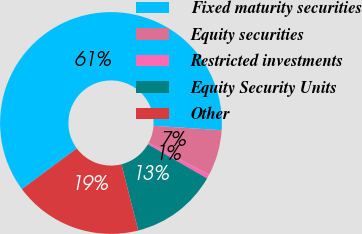Convert chart to OTSL. <chart><loc_0><loc_0><loc_500><loc_500><pie_chart><fcel>Fixed maturity securities<fcel>Equity securities<fcel>Restricted investments<fcel>Equity Security Units<fcel>Other<nl><fcel>61.2%<fcel>6.67%<fcel>0.61%<fcel>12.73%<fcel>18.79%<nl></chart> 